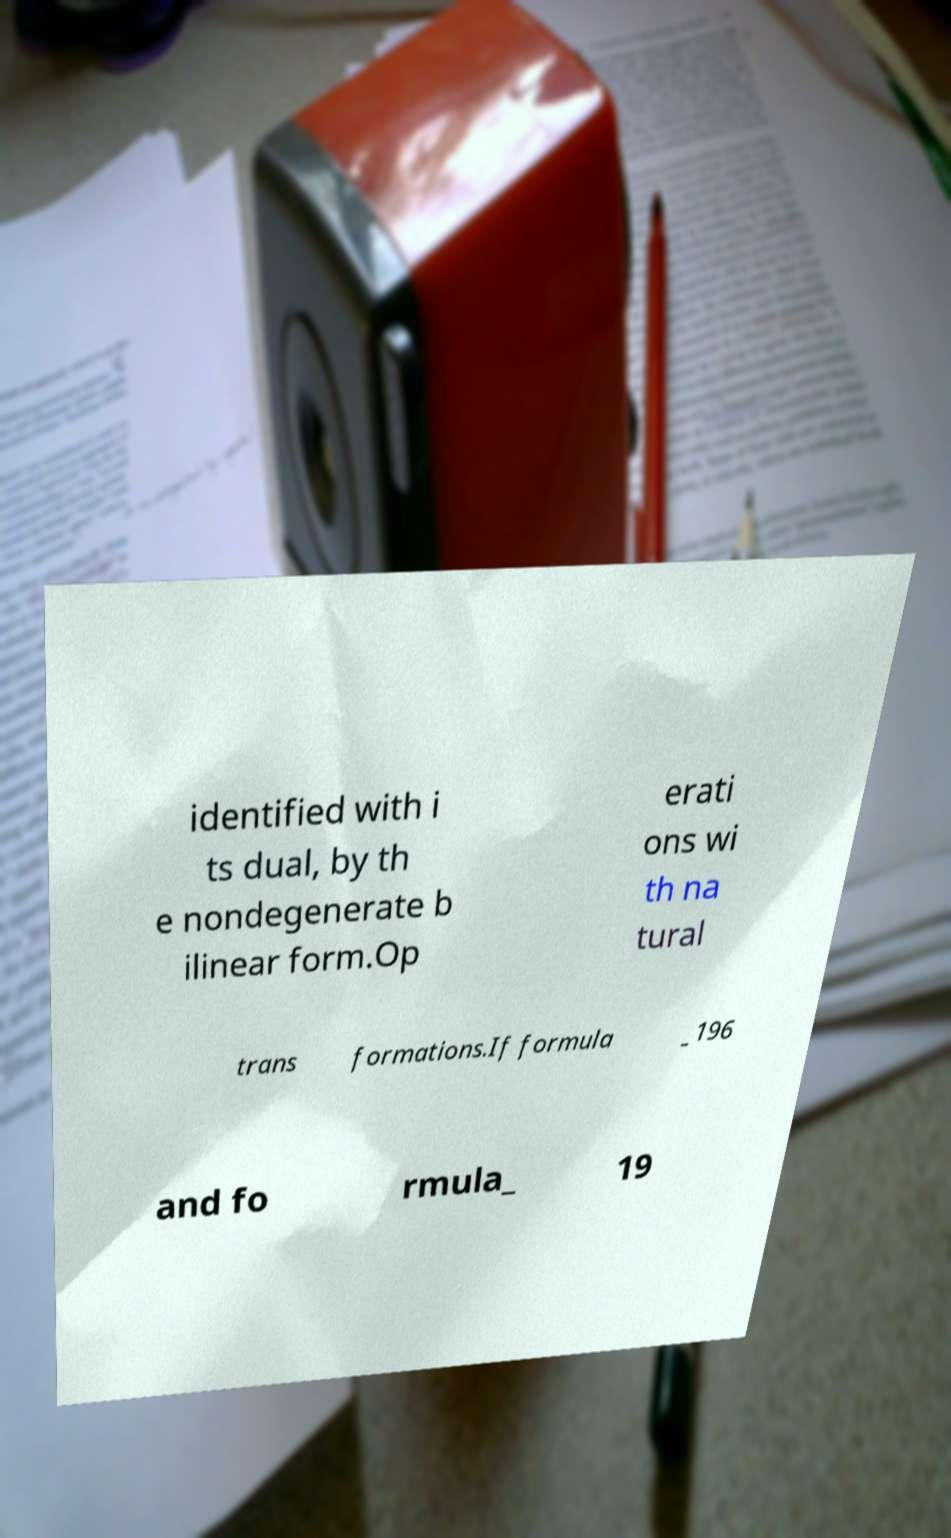For documentation purposes, I need the text within this image transcribed. Could you provide that? identified with i ts dual, by th e nondegenerate b ilinear form.Op erati ons wi th na tural trans formations.If formula _196 and fo rmula_ 19 